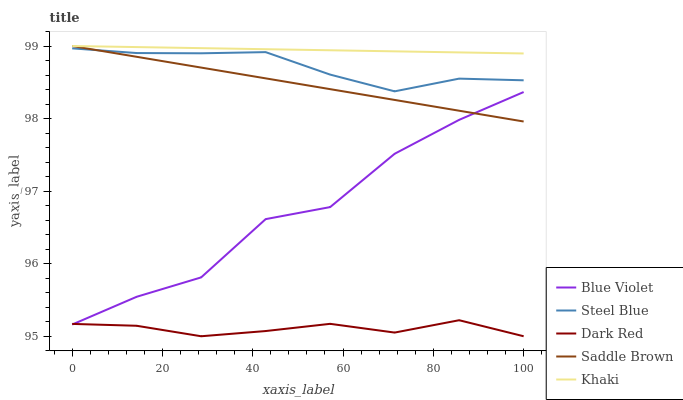Does Steel Blue have the minimum area under the curve?
Answer yes or no. No. Does Steel Blue have the maximum area under the curve?
Answer yes or no. No. Is Khaki the smoothest?
Answer yes or no. No. Is Khaki the roughest?
Answer yes or no. No. Does Steel Blue have the lowest value?
Answer yes or no. No. Does Steel Blue have the highest value?
Answer yes or no. No. Is Dark Red less than Steel Blue?
Answer yes or no. Yes. Is Khaki greater than Steel Blue?
Answer yes or no. Yes. Does Dark Red intersect Steel Blue?
Answer yes or no. No. 